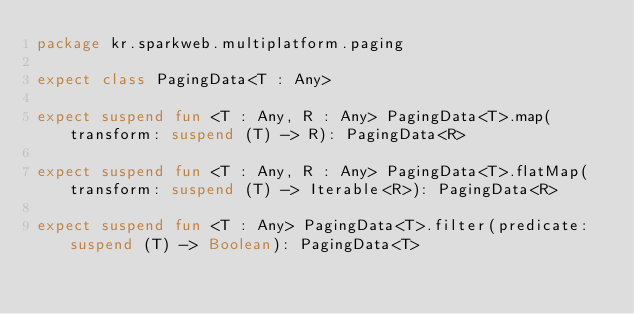<code> <loc_0><loc_0><loc_500><loc_500><_Kotlin_>package kr.sparkweb.multiplatform.paging

expect class PagingData<T : Any>

expect suspend fun <T : Any, R : Any> PagingData<T>.map(transform: suspend (T) -> R): PagingData<R>

expect suspend fun <T : Any, R : Any> PagingData<T>.flatMap(transform: suspend (T) -> Iterable<R>): PagingData<R>

expect suspend fun <T : Any> PagingData<T>.filter(predicate: suspend (T) -> Boolean): PagingData<T>
</code> 